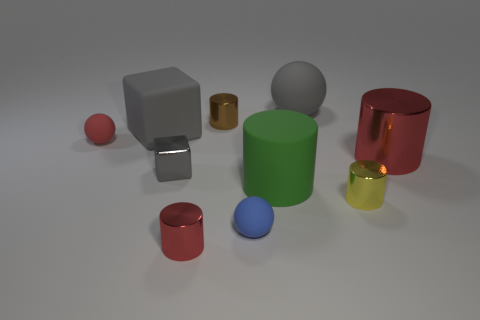Subtract all brown cylinders. How many cylinders are left? 4 Subtract all large cylinders. How many cylinders are left? 3 Subtract all purple cylinders. Subtract all red spheres. How many cylinders are left? 5 Subtract all cubes. How many objects are left? 8 Add 2 large green cylinders. How many large green cylinders are left? 3 Add 8 gray shiny blocks. How many gray shiny blocks exist? 9 Subtract 0 brown blocks. How many objects are left? 10 Subtract all small red cylinders. Subtract all yellow rubber spheres. How many objects are left? 9 